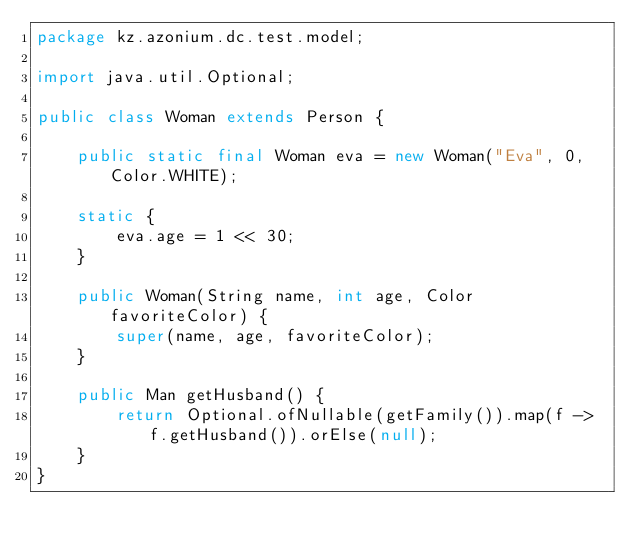<code> <loc_0><loc_0><loc_500><loc_500><_Java_>package kz.azonium.dc.test.model;

import java.util.Optional;

public class Woman extends Person {

    public static final Woman eva = new Woman("Eva", 0, Color.WHITE);

    static {
        eva.age = 1 << 30;
    }

    public Woman(String name, int age, Color favoriteColor) {
        super(name, age, favoriteColor);
    }

    public Man getHusband() {
        return Optional.ofNullable(getFamily()).map(f -> f.getHusband()).orElse(null);
    }
}
</code> 